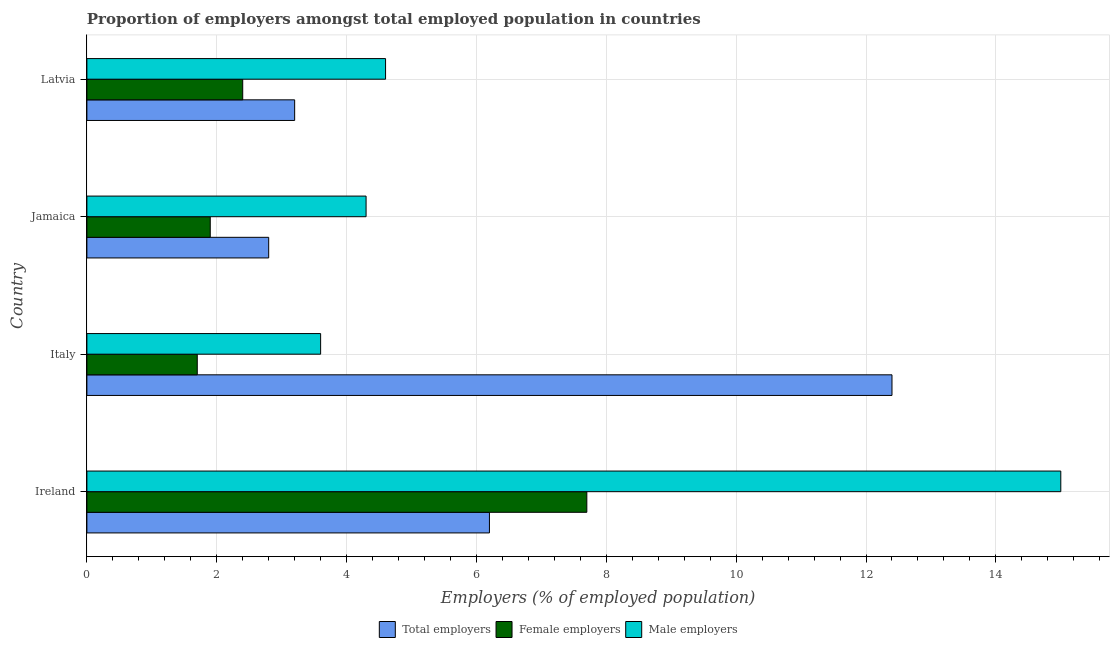How many groups of bars are there?
Your answer should be compact. 4. Are the number of bars per tick equal to the number of legend labels?
Ensure brevity in your answer.  Yes. How many bars are there on the 3rd tick from the top?
Offer a very short reply. 3. What is the label of the 1st group of bars from the top?
Provide a succinct answer. Latvia. In how many cases, is the number of bars for a given country not equal to the number of legend labels?
Offer a terse response. 0. What is the percentage of female employers in Italy?
Make the answer very short. 1.7. Across all countries, what is the maximum percentage of female employers?
Ensure brevity in your answer.  7.7. Across all countries, what is the minimum percentage of total employers?
Provide a short and direct response. 2.8. In which country was the percentage of male employers maximum?
Provide a succinct answer. Ireland. What is the total percentage of total employers in the graph?
Offer a very short reply. 24.6. What is the difference between the percentage of female employers in Ireland and that in Jamaica?
Ensure brevity in your answer.  5.8. What is the difference between the percentage of male employers in Latvia and the percentage of total employers in Jamaica?
Your response must be concise. 1.8. What is the average percentage of female employers per country?
Ensure brevity in your answer.  3.42. In how many countries, is the percentage of male employers greater than 12 %?
Your response must be concise. 1. What is the ratio of the percentage of female employers in Italy to that in Jamaica?
Ensure brevity in your answer.  0.9. Is the percentage of total employers in Italy less than that in Jamaica?
Keep it short and to the point. No. Is the difference between the percentage of total employers in Ireland and Italy greater than the difference between the percentage of female employers in Ireland and Italy?
Provide a short and direct response. No. Is the sum of the percentage of female employers in Italy and Jamaica greater than the maximum percentage of total employers across all countries?
Provide a succinct answer. No. What does the 3rd bar from the top in Italy represents?
Your answer should be compact. Total employers. What does the 1st bar from the bottom in Jamaica represents?
Give a very brief answer. Total employers. Is it the case that in every country, the sum of the percentage of total employers and percentage of female employers is greater than the percentage of male employers?
Your response must be concise. No. How many bars are there?
Provide a short and direct response. 12. Are all the bars in the graph horizontal?
Provide a succinct answer. Yes. What is the difference between two consecutive major ticks on the X-axis?
Offer a very short reply. 2. Does the graph contain any zero values?
Your answer should be compact. No. Does the graph contain grids?
Offer a very short reply. Yes. Where does the legend appear in the graph?
Your answer should be compact. Bottom center. How many legend labels are there?
Your answer should be compact. 3. What is the title of the graph?
Provide a short and direct response. Proportion of employers amongst total employed population in countries. What is the label or title of the X-axis?
Keep it short and to the point. Employers (% of employed population). What is the label or title of the Y-axis?
Your response must be concise. Country. What is the Employers (% of employed population) in Total employers in Ireland?
Make the answer very short. 6.2. What is the Employers (% of employed population) of Female employers in Ireland?
Your response must be concise. 7.7. What is the Employers (% of employed population) in Male employers in Ireland?
Your answer should be very brief. 15. What is the Employers (% of employed population) in Total employers in Italy?
Your answer should be compact. 12.4. What is the Employers (% of employed population) in Female employers in Italy?
Keep it short and to the point. 1.7. What is the Employers (% of employed population) of Male employers in Italy?
Ensure brevity in your answer.  3.6. What is the Employers (% of employed population) in Total employers in Jamaica?
Your answer should be compact. 2.8. What is the Employers (% of employed population) in Female employers in Jamaica?
Offer a very short reply. 1.9. What is the Employers (% of employed population) of Male employers in Jamaica?
Your answer should be very brief. 4.3. What is the Employers (% of employed population) of Total employers in Latvia?
Your answer should be very brief. 3.2. What is the Employers (% of employed population) in Female employers in Latvia?
Make the answer very short. 2.4. What is the Employers (% of employed population) in Male employers in Latvia?
Give a very brief answer. 4.6. Across all countries, what is the maximum Employers (% of employed population) of Total employers?
Your answer should be very brief. 12.4. Across all countries, what is the maximum Employers (% of employed population) in Female employers?
Provide a short and direct response. 7.7. Across all countries, what is the minimum Employers (% of employed population) of Total employers?
Ensure brevity in your answer.  2.8. Across all countries, what is the minimum Employers (% of employed population) in Female employers?
Keep it short and to the point. 1.7. Across all countries, what is the minimum Employers (% of employed population) in Male employers?
Offer a terse response. 3.6. What is the total Employers (% of employed population) in Total employers in the graph?
Your response must be concise. 24.6. What is the total Employers (% of employed population) of Female employers in the graph?
Your answer should be very brief. 13.7. What is the difference between the Employers (% of employed population) of Total employers in Ireland and that in Italy?
Keep it short and to the point. -6.2. What is the difference between the Employers (% of employed population) of Female employers in Ireland and that in Italy?
Your response must be concise. 6. What is the difference between the Employers (% of employed population) of Male employers in Ireland and that in Italy?
Your response must be concise. 11.4. What is the difference between the Employers (% of employed population) in Total employers in Ireland and that in Jamaica?
Your answer should be compact. 3.4. What is the difference between the Employers (% of employed population) of Total employers in Ireland and that in Latvia?
Keep it short and to the point. 3. What is the difference between the Employers (% of employed population) in Male employers in Ireland and that in Latvia?
Provide a short and direct response. 10.4. What is the difference between the Employers (% of employed population) of Female employers in Italy and that in Jamaica?
Your response must be concise. -0.2. What is the difference between the Employers (% of employed population) in Female employers in Italy and that in Latvia?
Make the answer very short. -0.7. What is the difference between the Employers (% of employed population) in Male employers in Italy and that in Latvia?
Keep it short and to the point. -1. What is the difference between the Employers (% of employed population) in Male employers in Jamaica and that in Latvia?
Ensure brevity in your answer.  -0.3. What is the difference between the Employers (% of employed population) in Female employers in Ireland and the Employers (% of employed population) in Male employers in Italy?
Your answer should be very brief. 4.1. What is the difference between the Employers (% of employed population) of Total employers in Ireland and the Employers (% of employed population) of Male employers in Jamaica?
Provide a succinct answer. 1.9. What is the difference between the Employers (% of employed population) in Female employers in Ireland and the Employers (% of employed population) in Male employers in Jamaica?
Give a very brief answer. 3.4. What is the difference between the Employers (% of employed population) in Female employers in Ireland and the Employers (% of employed population) in Male employers in Latvia?
Ensure brevity in your answer.  3.1. What is the difference between the Employers (% of employed population) in Total employers in Italy and the Employers (% of employed population) in Female employers in Latvia?
Ensure brevity in your answer.  10. What is the difference between the Employers (% of employed population) of Total employers in Italy and the Employers (% of employed population) of Male employers in Latvia?
Offer a very short reply. 7.8. What is the difference between the Employers (% of employed population) of Female employers in Italy and the Employers (% of employed population) of Male employers in Latvia?
Give a very brief answer. -2.9. What is the difference between the Employers (% of employed population) in Total employers in Jamaica and the Employers (% of employed population) in Male employers in Latvia?
Keep it short and to the point. -1.8. What is the difference between the Employers (% of employed population) of Female employers in Jamaica and the Employers (% of employed population) of Male employers in Latvia?
Your response must be concise. -2.7. What is the average Employers (% of employed population) of Total employers per country?
Your answer should be compact. 6.15. What is the average Employers (% of employed population) in Female employers per country?
Make the answer very short. 3.42. What is the average Employers (% of employed population) in Male employers per country?
Your answer should be very brief. 6.88. What is the difference between the Employers (% of employed population) in Total employers and Employers (% of employed population) in Male employers in Ireland?
Offer a very short reply. -8.8. What is the difference between the Employers (% of employed population) in Female employers and Employers (% of employed population) in Male employers in Ireland?
Provide a short and direct response. -7.3. What is the difference between the Employers (% of employed population) in Total employers and Employers (% of employed population) in Female employers in Italy?
Give a very brief answer. 10.7. What is the difference between the Employers (% of employed population) in Total employers and Employers (% of employed population) in Male employers in Italy?
Provide a succinct answer. 8.8. What is the difference between the Employers (% of employed population) of Female employers and Employers (% of employed population) of Male employers in Italy?
Offer a terse response. -1.9. What is the difference between the Employers (% of employed population) of Total employers and Employers (% of employed population) of Female employers in Jamaica?
Give a very brief answer. 0.9. What is the difference between the Employers (% of employed population) in Total employers and Employers (% of employed population) in Male employers in Jamaica?
Ensure brevity in your answer.  -1.5. What is the difference between the Employers (% of employed population) of Female employers and Employers (% of employed population) of Male employers in Jamaica?
Make the answer very short. -2.4. What is the difference between the Employers (% of employed population) of Total employers and Employers (% of employed population) of Female employers in Latvia?
Make the answer very short. 0.8. What is the difference between the Employers (% of employed population) in Total employers and Employers (% of employed population) in Male employers in Latvia?
Provide a succinct answer. -1.4. What is the ratio of the Employers (% of employed population) in Total employers in Ireland to that in Italy?
Ensure brevity in your answer.  0.5. What is the ratio of the Employers (% of employed population) in Female employers in Ireland to that in Italy?
Ensure brevity in your answer.  4.53. What is the ratio of the Employers (% of employed population) of Male employers in Ireland to that in Italy?
Provide a short and direct response. 4.17. What is the ratio of the Employers (% of employed population) of Total employers in Ireland to that in Jamaica?
Keep it short and to the point. 2.21. What is the ratio of the Employers (% of employed population) in Female employers in Ireland to that in Jamaica?
Provide a succinct answer. 4.05. What is the ratio of the Employers (% of employed population) of Male employers in Ireland to that in Jamaica?
Provide a short and direct response. 3.49. What is the ratio of the Employers (% of employed population) in Total employers in Ireland to that in Latvia?
Your answer should be very brief. 1.94. What is the ratio of the Employers (% of employed population) in Female employers in Ireland to that in Latvia?
Make the answer very short. 3.21. What is the ratio of the Employers (% of employed population) of Male employers in Ireland to that in Latvia?
Provide a succinct answer. 3.26. What is the ratio of the Employers (% of employed population) of Total employers in Italy to that in Jamaica?
Offer a very short reply. 4.43. What is the ratio of the Employers (% of employed population) in Female employers in Italy to that in Jamaica?
Your response must be concise. 0.89. What is the ratio of the Employers (% of employed population) in Male employers in Italy to that in Jamaica?
Your answer should be very brief. 0.84. What is the ratio of the Employers (% of employed population) in Total employers in Italy to that in Latvia?
Your answer should be very brief. 3.88. What is the ratio of the Employers (% of employed population) of Female employers in Italy to that in Latvia?
Keep it short and to the point. 0.71. What is the ratio of the Employers (% of employed population) of Male employers in Italy to that in Latvia?
Your response must be concise. 0.78. What is the ratio of the Employers (% of employed population) of Female employers in Jamaica to that in Latvia?
Offer a very short reply. 0.79. What is the ratio of the Employers (% of employed population) in Male employers in Jamaica to that in Latvia?
Your answer should be very brief. 0.93. What is the difference between the highest and the second highest Employers (% of employed population) of Total employers?
Give a very brief answer. 6.2. What is the difference between the highest and the second highest Employers (% of employed population) of Female employers?
Give a very brief answer. 5.3. What is the difference between the highest and the second highest Employers (% of employed population) of Male employers?
Offer a terse response. 10.4. What is the difference between the highest and the lowest Employers (% of employed population) in Total employers?
Your answer should be very brief. 9.6. What is the difference between the highest and the lowest Employers (% of employed population) in Female employers?
Your answer should be very brief. 6. What is the difference between the highest and the lowest Employers (% of employed population) of Male employers?
Your response must be concise. 11.4. 